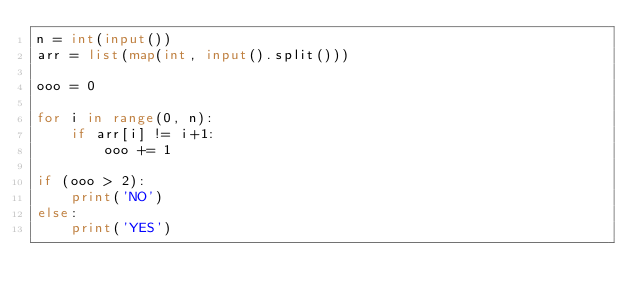Convert code to text. <code><loc_0><loc_0><loc_500><loc_500><_Python_>n = int(input())
arr = list(map(int, input().split()))

ooo = 0

for i in range(0, n):
    if arr[i] != i+1:
        ooo += 1

if (ooo > 2):
    print('NO')
else:
    print('YES')</code> 